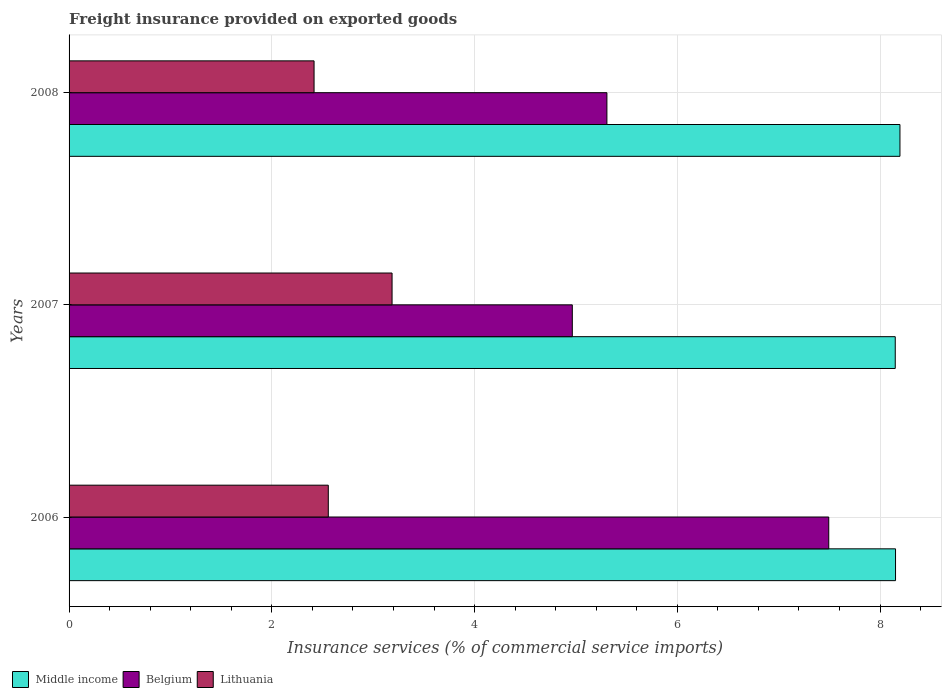Are the number of bars per tick equal to the number of legend labels?
Keep it short and to the point. Yes. What is the label of the 1st group of bars from the top?
Provide a succinct answer. 2008. What is the freight insurance provided on exported goods in Belgium in 2008?
Keep it short and to the point. 5.31. Across all years, what is the maximum freight insurance provided on exported goods in Middle income?
Provide a short and direct response. 8.2. Across all years, what is the minimum freight insurance provided on exported goods in Lithuania?
Offer a very short reply. 2.42. What is the total freight insurance provided on exported goods in Belgium in the graph?
Your response must be concise. 17.76. What is the difference between the freight insurance provided on exported goods in Belgium in 2006 and that in 2007?
Offer a terse response. 2.53. What is the difference between the freight insurance provided on exported goods in Lithuania in 2008 and the freight insurance provided on exported goods in Middle income in 2007?
Your answer should be compact. -5.73. What is the average freight insurance provided on exported goods in Belgium per year?
Offer a very short reply. 5.92. In the year 2006, what is the difference between the freight insurance provided on exported goods in Lithuania and freight insurance provided on exported goods in Middle income?
Give a very brief answer. -5.6. In how many years, is the freight insurance provided on exported goods in Belgium greater than 6 %?
Offer a very short reply. 1. What is the ratio of the freight insurance provided on exported goods in Belgium in 2007 to that in 2008?
Your answer should be compact. 0.94. Is the freight insurance provided on exported goods in Middle income in 2006 less than that in 2008?
Offer a very short reply. Yes. Is the difference between the freight insurance provided on exported goods in Lithuania in 2006 and 2007 greater than the difference between the freight insurance provided on exported goods in Middle income in 2006 and 2007?
Ensure brevity in your answer.  No. What is the difference between the highest and the second highest freight insurance provided on exported goods in Lithuania?
Ensure brevity in your answer.  0.63. What is the difference between the highest and the lowest freight insurance provided on exported goods in Middle income?
Ensure brevity in your answer.  0.05. In how many years, is the freight insurance provided on exported goods in Belgium greater than the average freight insurance provided on exported goods in Belgium taken over all years?
Provide a succinct answer. 1. Is the sum of the freight insurance provided on exported goods in Lithuania in 2006 and 2007 greater than the maximum freight insurance provided on exported goods in Middle income across all years?
Offer a terse response. No. What does the 3rd bar from the top in 2007 represents?
Make the answer very short. Middle income. What does the 3rd bar from the bottom in 2007 represents?
Give a very brief answer. Lithuania. Is it the case that in every year, the sum of the freight insurance provided on exported goods in Middle income and freight insurance provided on exported goods in Belgium is greater than the freight insurance provided on exported goods in Lithuania?
Make the answer very short. Yes. Are all the bars in the graph horizontal?
Your answer should be compact. Yes. Are the values on the major ticks of X-axis written in scientific E-notation?
Provide a short and direct response. No. Does the graph contain grids?
Ensure brevity in your answer.  Yes. Where does the legend appear in the graph?
Your response must be concise. Bottom left. How are the legend labels stacked?
Provide a short and direct response. Horizontal. What is the title of the graph?
Provide a succinct answer. Freight insurance provided on exported goods. What is the label or title of the X-axis?
Your response must be concise. Insurance services (% of commercial service imports). What is the Insurance services (% of commercial service imports) of Middle income in 2006?
Make the answer very short. 8.15. What is the Insurance services (% of commercial service imports) in Belgium in 2006?
Provide a succinct answer. 7.49. What is the Insurance services (% of commercial service imports) in Lithuania in 2006?
Provide a succinct answer. 2.56. What is the Insurance services (% of commercial service imports) of Middle income in 2007?
Keep it short and to the point. 8.15. What is the Insurance services (% of commercial service imports) of Belgium in 2007?
Provide a succinct answer. 4.96. What is the Insurance services (% of commercial service imports) of Lithuania in 2007?
Your response must be concise. 3.19. What is the Insurance services (% of commercial service imports) of Middle income in 2008?
Provide a short and direct response. 8.2. What is the Insurance services (% of commercial service imports) in Belgium in 2008?
Ensure brevity in your answer.  5.31. What is the Insurance services (% of commercial service imports) of Lithuania in 2008?
Give a very brief answer. 2.42. Across all years, what is the maximum Insurance services (% of commercial service imports) of Middle income?
Your response must be concise. 8.2. Across all years, what is the maximum Insurance services (% of commercial service imports) in Belgium?
Offer a very short reply. 7.49. Across all years, what is the maximum Insurance services (% of commercial service imports) of Lithuania?
Ensure brevity in your answer.  3.19. Across all years, what is the minimum Insurance services (% of commercial service imports) in Middle income?
Your answer should be compact. 8.15. Across all years, what is the minimum Insurance services (% of commercial service imports) in Belgium?
Provide a succinct answer. 4.96. Across all years, what is the minimum Insurance services (% of commercial service imports) in Lithuania?
Your answer should be very brief. 2.42. What is the total Insurance services (% of commercial service imports) of Middle income in the graph?
Provide a succinct answer. 24.5. What is the total Insurance services (% of commercial service imports) in Belgium in the graph?
Provide a succinct answer. 17.76. What is the total Insurance services (% of commercial service imports) in Lithuania in the graph?
Offer a very short reply. 8.16. What is the difference between the Insurance services (% of commercial service imports) in Middle income in 2006 and that in 2007?
Your response must be concise. 0. What is the difference between the Insurance services (% of commercial service imports) of Belgium in 2006 and that in 2007?
Make the answer very short. 2.53. What is the difference between the Insurance services (% of commercial service imports) in Lithuania in 2006 and that in 2007?
Give a very brief answer. -0.63. What is the difference between the Insurance services (% of commercial service imports) in Middle income in 2006 and that in 2008?
Your answer should be compact. -0.04. What is the difference between the Insurance services (% of commercial service imports) of Belgium in 2006 and that in 2008?
Ensure brevity in your answer.  2.19. What is the difference between the Insurance services (% of commercial service imports) of Lithuania in 2006 and that in 2008?
Offer a terse response. 0.14. What is the difference between the Insurance services (% of commercial service imports) in Middle income in 2007 and that in 2008?
Keep it short and to the point. -0.05. What is the difference between the Insurance services (% of commercial service imports) of Belgium in 2007 and that in 2008?
Provide a short and direct response. -0.34. What is the difference between the Insurance services (% of commercial service imports) in Lithuania in 2007 and that in 2008?
Ensure brevity in your answer.  0.77. What is the difference between the Insurance services (% of commercial service imports) of Middle income in 2006 and the Insurance services (% of commercial service imports) of Belgium in 2007?
Your answer should be very brief. 3.19. What is the difference between the Insurance services (% of commercial service imports) of Middle income in 2006 and the Insurance services (% of commercial service imports) of Lithuania in 2007?
Your answer should be very brief. 4.97. What is the difference between the Insurance services (% of commercial service imports) in Belgium in 2006 and the Insurance services (% of commercial service imports) in Lithuania in 2007?
Offer a very short reply. 4.31. What is the difference between the Insurance services (% of commercial service imports) in Middle income in 2006 and the Insurance services (% of commercial service imports) in Belgium in 2008?
Make the answer very short. 2.85. What is the difference between the Insurance services (% of commercial service imports) in Middle income in 2006 and the Insurance services (% of commercial service imports) in Lithuania in 2008?
Offer a very short reply. 5.74. What is the difference between the Insurance services (% of commercial service imports) of Belgium in 2006 and the Insurance services (% of commercial service imports) of Lithuania in 2008?
Your answer should be compact. 5.08. What is the difference between the Insurance services (% of commercial service imports) in Middle income in 2007 and the Insurance services (% of commercial service imports) in Belgium in 2008?
Provide a short and direct response. 2.84. What is the difference between the Insurance services (% of commercial service imports) of Middle income in 2007 and the Insurance services (% of commercial service imports) of Lithuania in 2008?
Provide a succinct answer. 5.73. What is the difference between the Insurance services (% of commercial service imports) of Belgium in 2007 and the Insurance services (% of commercial service imports) of Lithuania in 2008?
Make the answer very short. 2.55. What is the average Insurance services (% of commercial service imports) in Middle income per year?
Offer a terse response. 8.17. What is the average Insurance services (% of commercial service imports) in Belgium per year?
Provide a short and direct response. 5.92. What is the average Insurance services (% of commercial service imports) of Lithuania per year?
Make the answer very short. 2.72. In the year 2006, what is the difference between the Insurance services (% of commercial service imports) in Middle income and Insurance services (% of commercial service imports) in Belgium?
Offer a terse response. 0.66. In the year 2006, what is the difference between the Insurance services (% of commercial service imports) of Middle income and Insurance services (% of commercial service imports) of Lithuania?
Offer a very short reply. 5.6. In the year 2006, what is the difference between the Insurance services (% of commercial service imports) of Belgium and Insurance services (% of commercial service imports) of Lithuania?
Make the answer very short. 4.94. In the year 2007, what is the difference between the Insurance services (% of commercial service imports) of Middle income and Insurance services (% of commercial service imports) of Belgium?
Your response must be concise. 3.19. In the year 2007, what is the difference between the Insurance services (% of commercial service imports) in Middle income and Insurance services (% of commercial service imports) in Lithuania?
Provide a succinct answer. 4.96. In the year 2007, what is the difference between the Insurance services (% of commercial service imports) in Belgium and Insurance services (% of commercial service imports) in Lithuania?
Your answer should be compact. 1.78. In the year 2008, what is the difference between the Insurance services (% of commercial service imports) in Middle income and Insurance services (% of commercial service imports) in Belgium?
Provide a short and direct response. 2.89. In the year 2008, what is the difference between the Insurance services (% of commercial service imports) in Middle income and Insurance services (% of commercial service imports) in Lithuania?
Offer a very short reply. 5.78. In the year 2008, what is the difference between the Insurance services (% of commercial service imports) of Belgium and Insurance services (% of commercial service imports) of Lithuania?
Give a very brief answer. 2.89. What is the ratio of the Insurance services (% of commercial service imports) of Middle income in 2006 to that in 2007?
Keep it short and to the point. 1. What is the ratio of the Insurance services (% of commercial service imports) in Belgium in 2006 to that in 2007?
Provide a succinct answer. 1.51. What is the ratio of the Insurance services (% of commercial service imports) in Lithuania in 2006 to that in 2007?
Provide a succinct answer. 0.8. What is the ratio of the Insurance services (% of commercial service imports) in Middle income in 2006 to that in 2008?
Provide a succinct answer. 0.99. What is the ratio of the Insurance services (% of commercial service imports) of Belgium in 2006 to that in 2008?
Ensure brevity in your answer.  1.41. What is the ratio of the Insurance services (% of commercial service imports) in Lithuania in 2006 to that in 2008?
Give a very brief answer. 1.06. What is the ratio of the Insurance services (% of commercial service imports) in Middle income in 2007 to that in 2008?
Your answer should be very brief. 0.99. What is the ratio of the Insurance services (% of commercial service imports) of Belgium in 2007 to that in 2008?
Offer a very short reply. 0.94. What is the ratio of the Insurance services (% of commercial service imports) of Lithuania in 2007 to that in 2008?
Ensure brevity in your answer.  1.32. What is the difference between the highest and the second highest Insurance services (% of commercial service imports) in Middle income?
Ensure brevity in your answer.  0.04. What is the difference between the highest and the second highest Insurance services (% of commercial service imports) in Belgium?
Your response must be concise. 2.19. What is the difference between the highest and the second highest Insurance services (% of commercial service imports) in Lithuania?
Your response must be concise. 0.63. What is the difference between the highest and the lowest Insurance services (% of commercial service imports) in Middle income?
Your answer should be very brief. 0.05. What is the difference between the highest and the lowest Insurance services (% of commercial service imports) of Belgium?
Offer a very short reply. 2.53. What is the difference between the highest and the lowest Insurance services (% of commercial service imports) of Lithuania?
Your answer should be very brief. 0.77. 